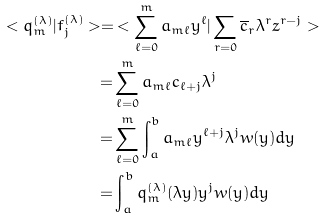<formula> <loc_0><loc_0><loc_500><loc_500>< q _ { m } ^ { ( \lambda ) } | f _ { j } ^ { ( \lambda ) } > = & < \sum _ { \ell = 0 } ^ { m } a _ { m \ell } y ^ { \ell } | \sum _ { r = 0 } \overline { c } _ { r } \lambda ^ { r } z ^ { r - j } > \\ = & \sum _ { \ell = 0 } ^ { m } a _ { m \ell } c _ { \ell + j } \lambda ^ { j } \\ = & \sum _ { \ell = 0 } ^ { m } \int _ { a } ^ { b } a _ { m \ell } y ^ { \ell + j } \lambda ^ { j } w ( y ) d y \\ = & \int _ { a } ^ { b } q _ { m } ^ { ( \lambda ) } ( \lambda y ) y ^ { j } w ( y ) d y \\</formula> 